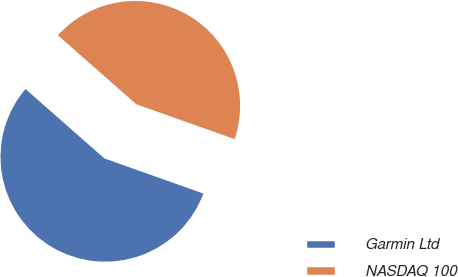<chart> <loc_0><loc_0><loc_500><loc_500><pie_chart><fcel>Garmin Ltd<fcel>NASDAQ 100<nl><fcel>56.06%<fcel>43.94%<nl></chart> 